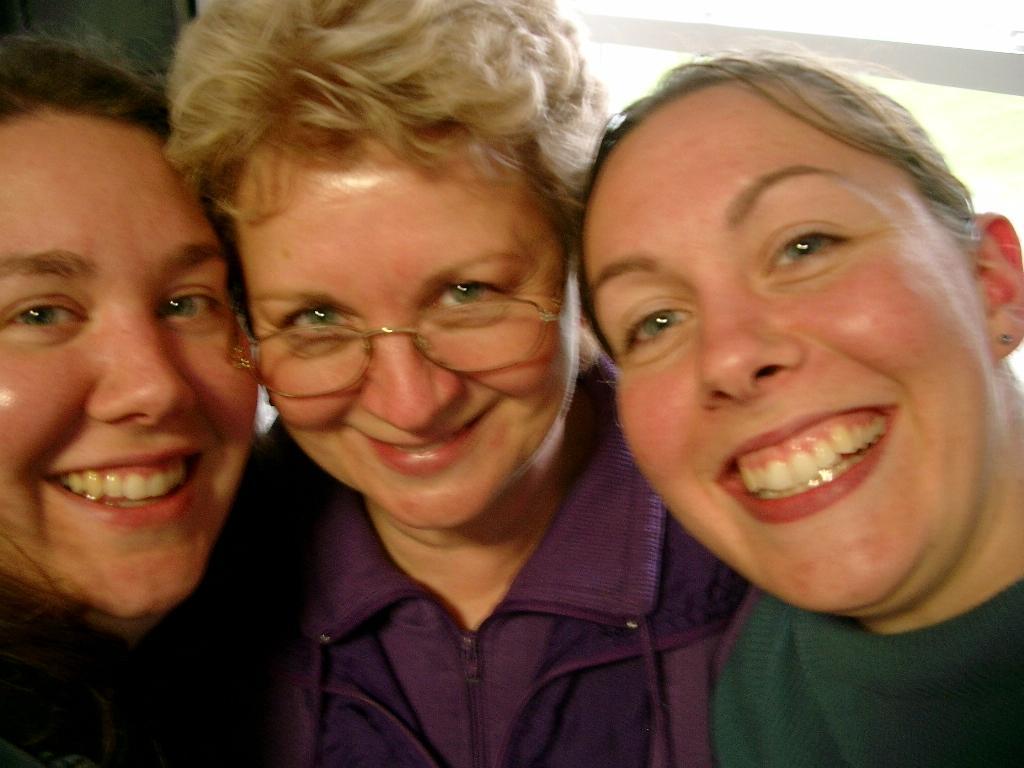How would you summarize this image in a sentence or two? In the image three women are standing and smiling. 